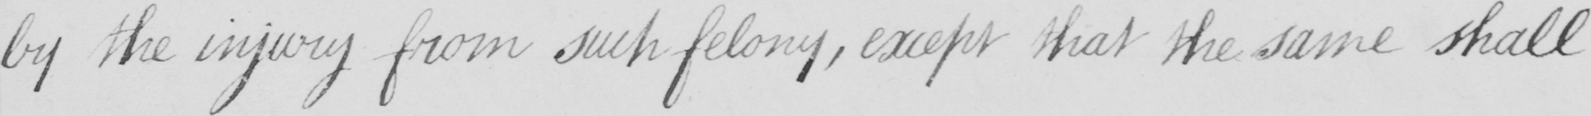Please provide the text content of this handwritten line. by the injury from such felony , except that the same shall 